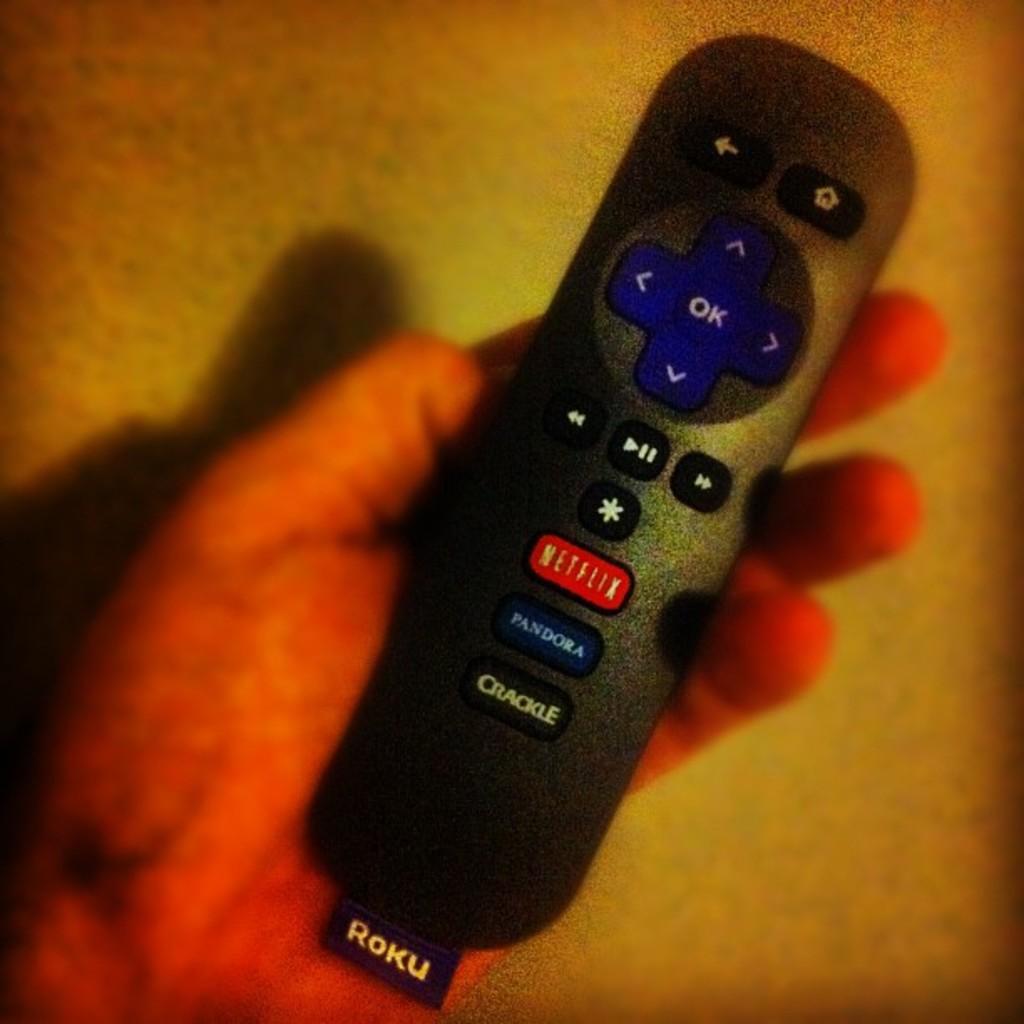Is this a remote?
Offer a terse response. Yes. What is the name at the bottom of this remote?
Make the answer very short. Roku. 